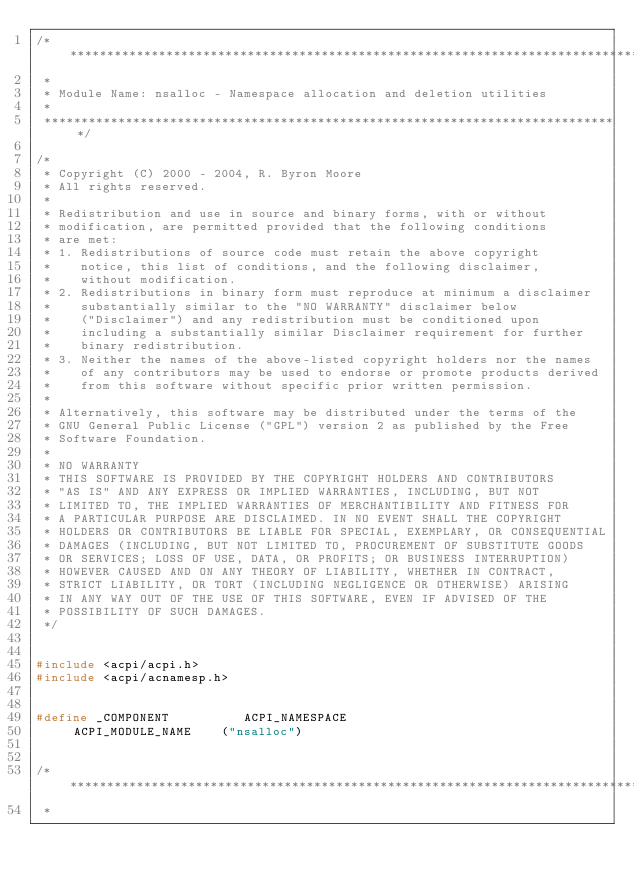Convert code to text. <code><loc_0><loc_0><loc_500><loc_500><_C_>/*******************************************************************************
 *
 * Module Name: nsalloc - Namespace allocation and deletion utilities
 *
 ******************************************************************************/

/*
 * Copyright (C) 2000 - 2004, R. Byron Moore
 * All rights reserved.
 *
 * Redistribution and use in source and binary forms, with or without
 * modification, are permitted provided that the following conditions
 * are met:
 * 1. Redistributions of source code must retain the above copyright
 *    notice, this list of conditions, and the following disclaimer,
 *    without modification.
 * 2. Redistributions in binary form must reproduce at minimum a disclaimer
 *    substantially similar to the "NO WARRANTY" disclaimer below
 *    ("Disclaimer") and any redistribution must be conditioned upon
 *    including a substantially similar Disclaimer requirement for further
 *    binary redistribution.
 * 3. Neither the names of the above-listed copyright holders nor the names
 *    of any contributors may be used to endorse or promote products derived
 *    from this software without specific prior written permission.
 *
 * Alternatively, this software may be distributed under the terms of the
 * GNU General Public License ("GPL") version 2 as published by the Free
 * Software Foundation.
 *
 * NO WARRANTY
 * THIS SOFTWARE IS PROVIDED BY THE COPYRIGHT HOLDERS AND CONTRIBUTORS
 * "AS IS" AND ANY EXPRESS OR IMPLIED WARRANTIES, INCLUDING, BUT NOT
 * LIMITED TO, THE IMPLIED WARRANTIES OF MERCHANTIBILITY AND FITNESS FOR
 * A PARTICULAR PURPOSE ARE DISCLAIMED. IN NO EVENT SHALL THE COPYRIGHT
 * HOLDERS OR CONTRIBUTORS BE LIABLE FOR SPECIAL, EXEMPLARY, OR CONSEQUENTIAL
 * DAMAGES (INCLUDING, BUT NOT LIMITED TO, PROCUREMENT OF SUBSTITUTE GOODS
 * OR SERVICES; LOSS OF USE, DATA, OR PROFITS; OR BUSINESS INTERRUPTION)
 * HOWEVER CAUSED AND ON ANY THEORY OF LIABILITY, WHETHER IN CONTRACT,
 * STRICT LIABILITY, OR TORT (INCLUDING NEGLIGENCE OR OTHERWISE) ARISING
 * IN ANY WAY OUT OF THE USE OF THIS SOFTWARE, EVEN IF ADVISED OF THE
 * POSSIBILITY OF SUCH DAMAGES.
 */


#include <acpi/acpi.h>
#include <acpi/acnamesp.h>


#define _COMPONENT          ACPI_NAMESPACE
	 ACPI_MODULE_NAME    ("nsalloc")


/*******************************************************************************
 *</code> 